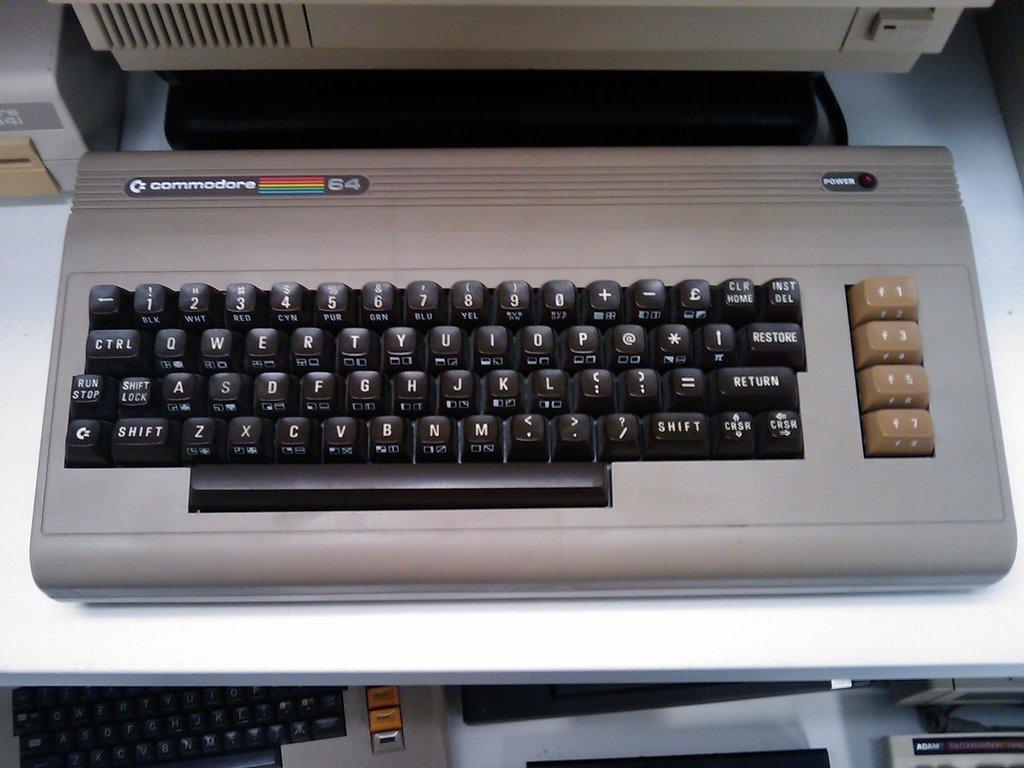What brand is the computer?
Your answer should be compact. Commodore. 